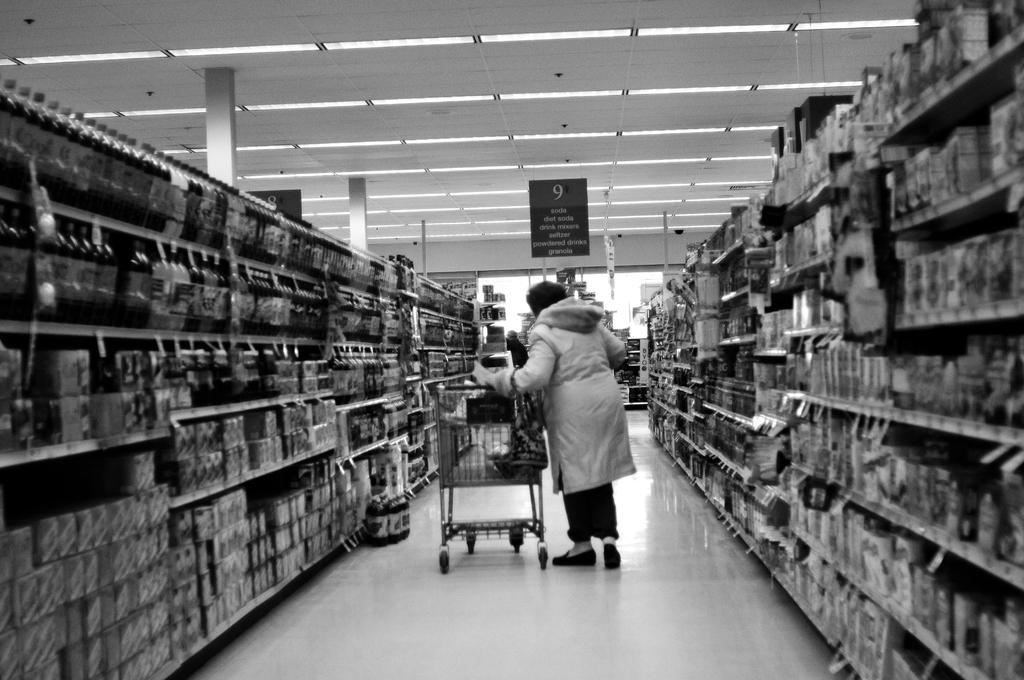Can a person buy soda in this aisle according to the sign?
Provide a succinct answer. Yes. What is the isle number?
Make the answer very short. 9. 